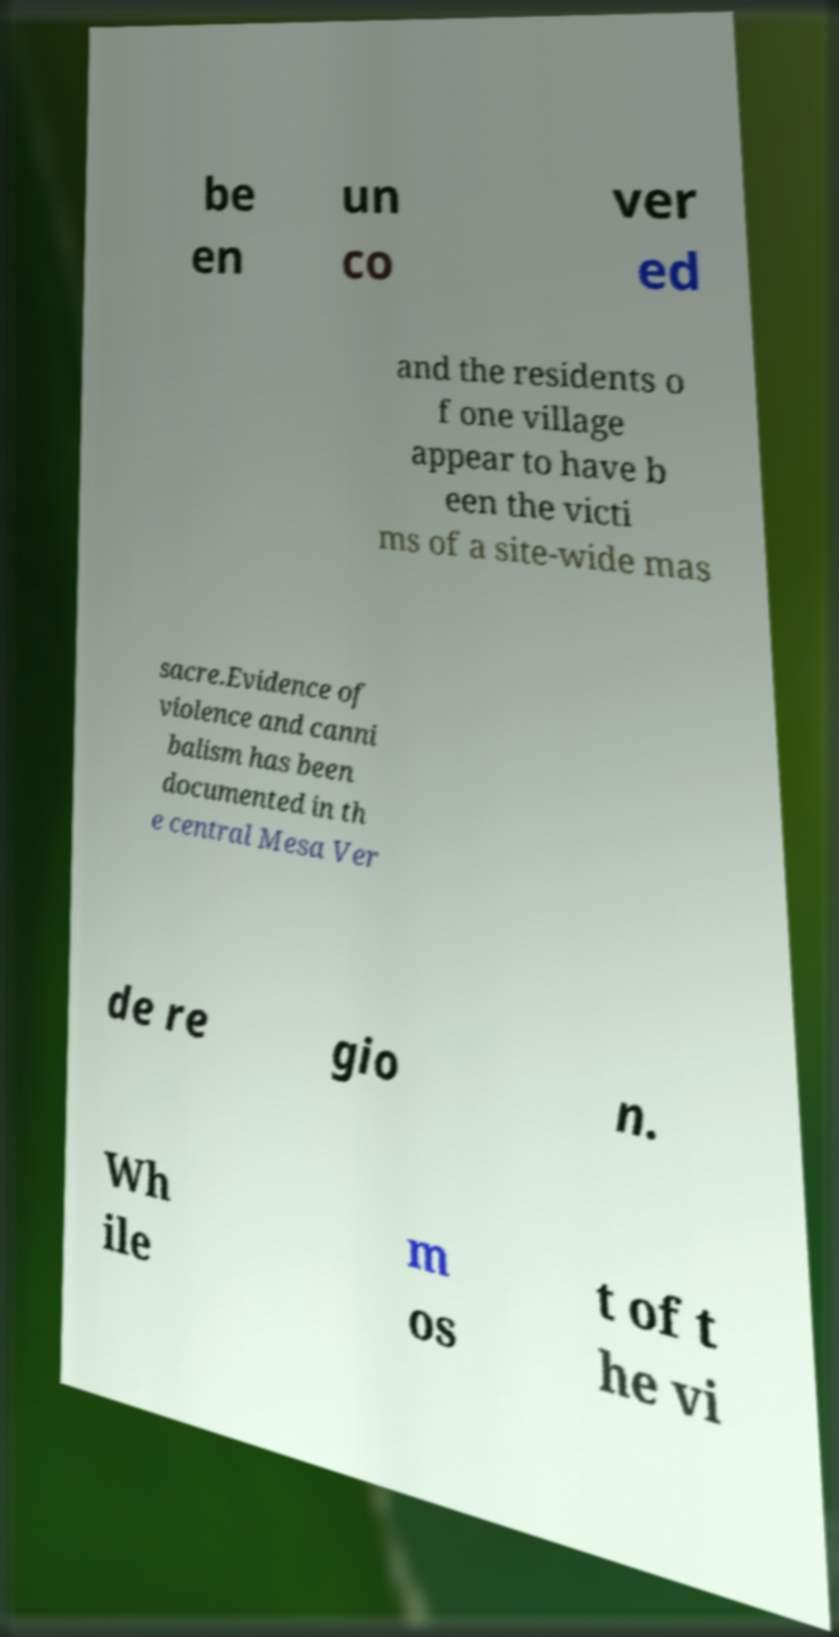Could you assist in decoding the text presented in this image and type it out clearly? be en un co ver ed and the residents o f one village appear to have b een the victi ms of a site-wide mas sacre.Evidence of violence and canni balism has been documented in th e central Mesa Ver de re gio n. Wh ile m os t of t he vi 